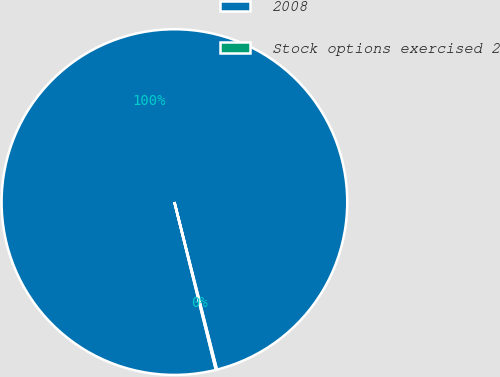Convert chart to OTSL. <chart><loc_0><loc_0><loc_500><loc_500><pie_chart><fcel>2008<fcel>Stock options exercised 2<nl><fcel>99.9%<fcel>0.1%<nl></chart> 